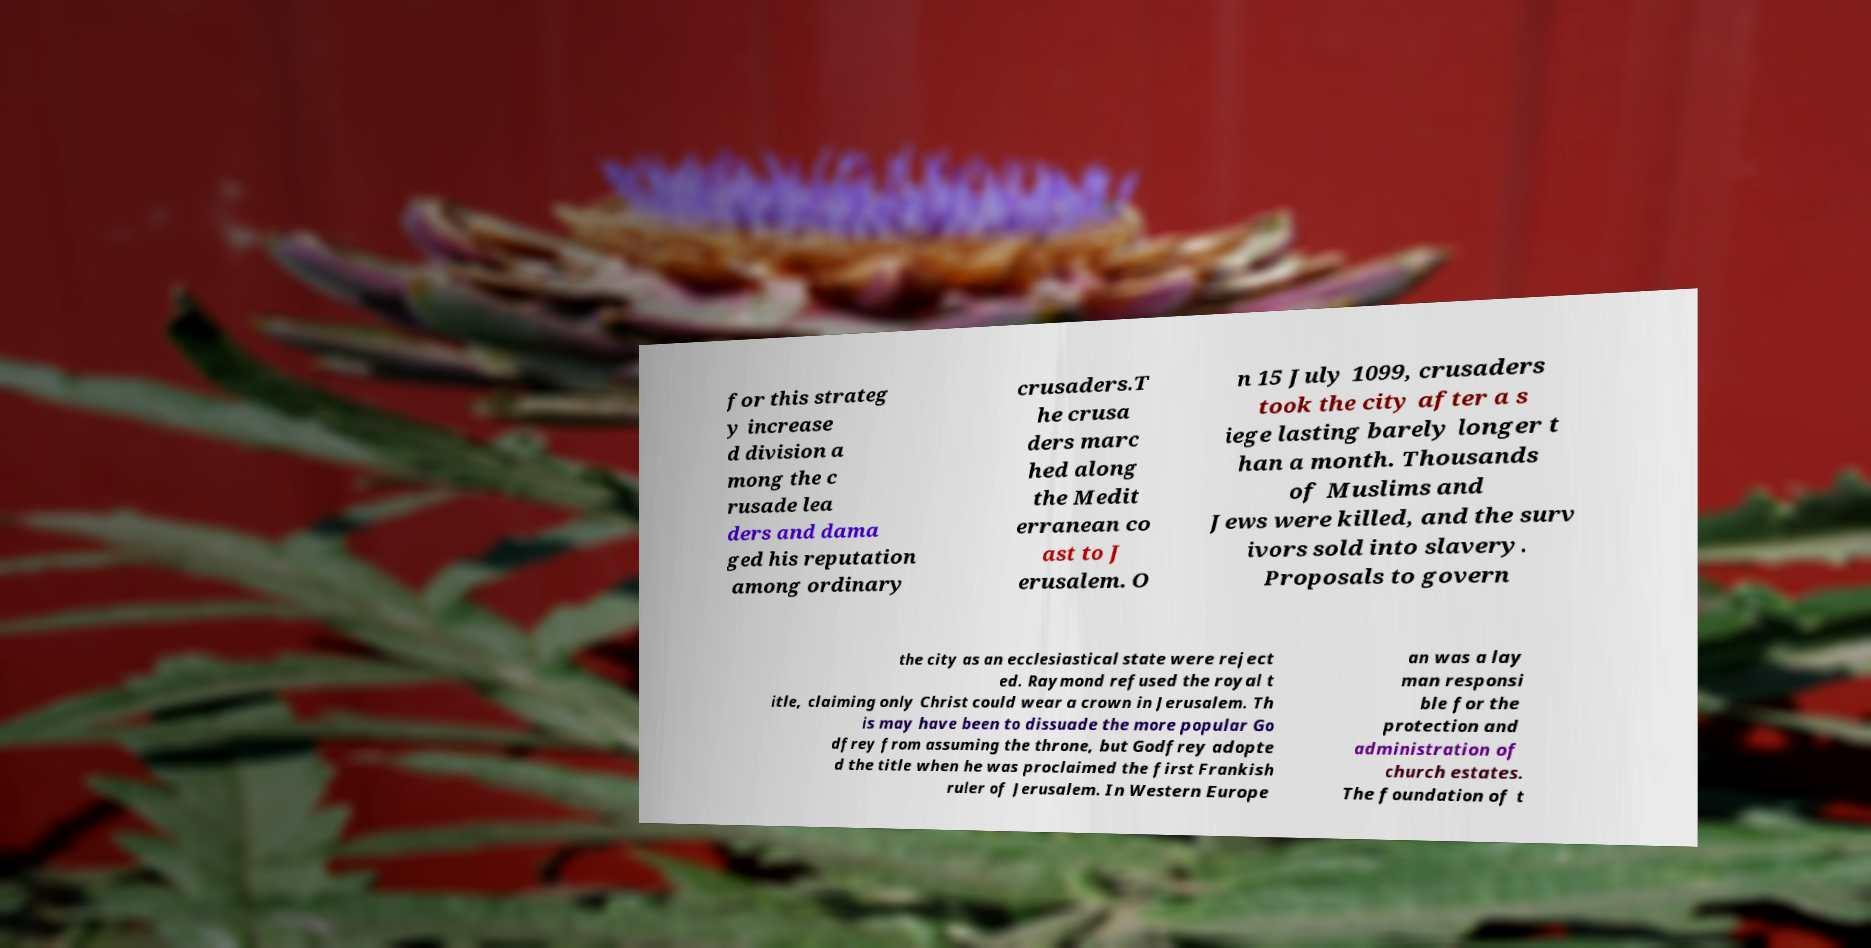Please read and relay the text visible in this image. What does it say? for this strateg y increase d division a mong the c rusade lea ders and dama ged his reputation among ordinary crusaders.T he crusa ders marc hed along the Medit erranean co ast to J erusalem. O n 15 July 1099, crusaders took the city after a s iege lasting barely longer t han a month. Thousands of Muslims and Jews were killed, and the surv ivors sold into slavery. Proposals to govern the city as an ecclesiastical state were reject ed. Raymond refused the royal t itle, claiming only Christ could wear a crown in Jerusalem. Th is may have been to dissuade the more popular Go dfrey from assuming the throne, but Godfrey adopte d the title when he was proclaimed the first Frankish ruler of Jerusalem. In Western Europe an was a lay man responsi ble for the protection and administration of church estates. The foundation of t 